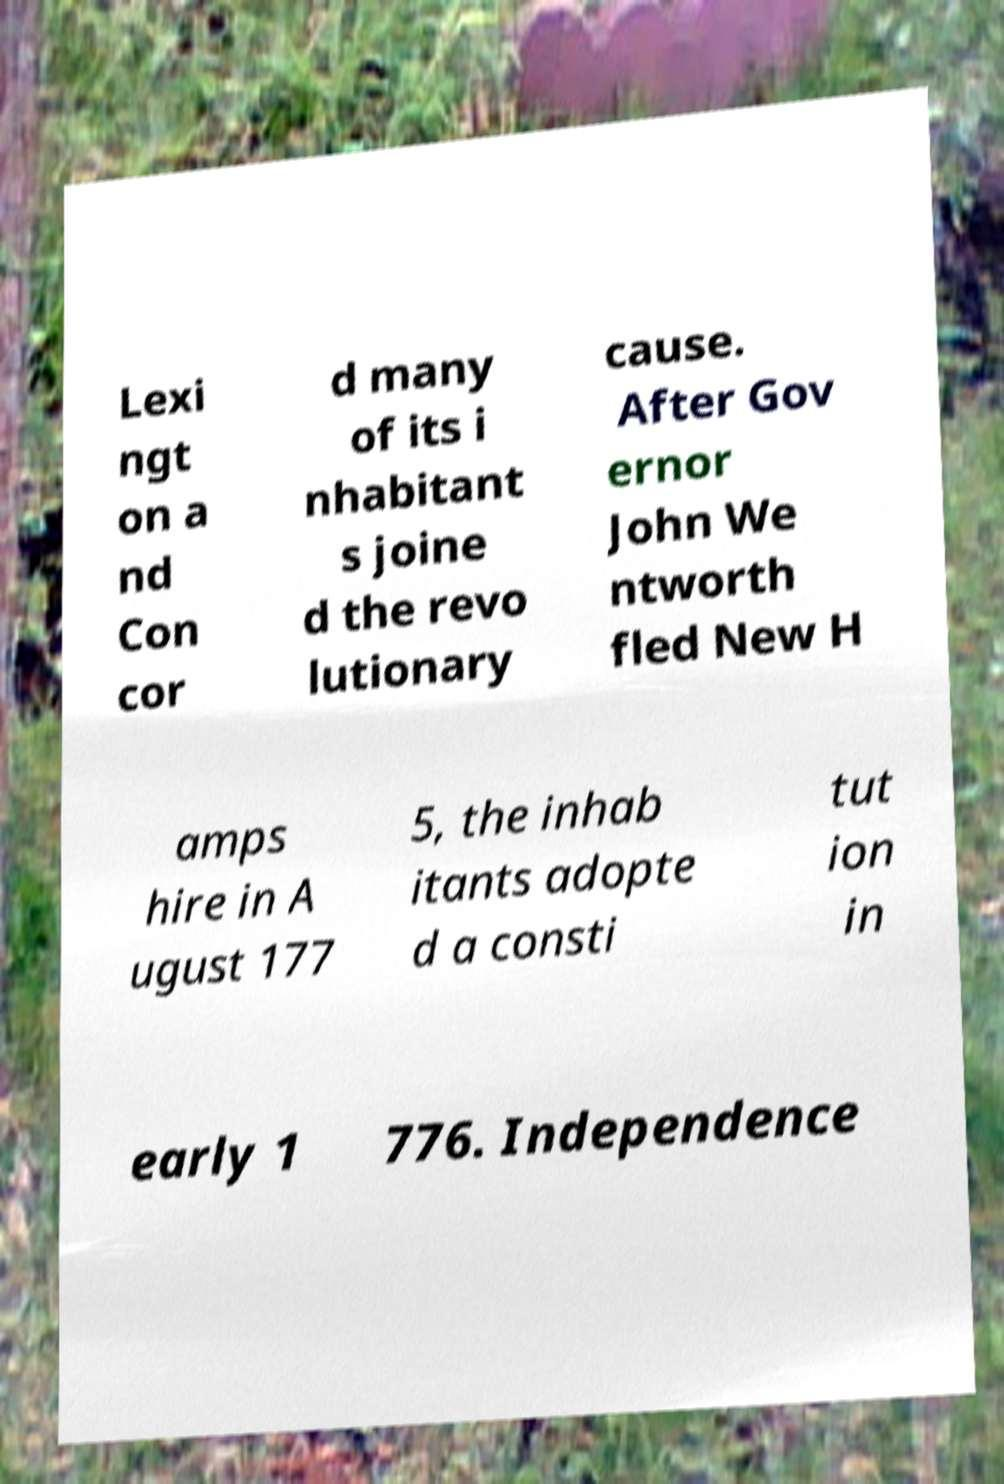Can you accurately transcribe the text from the provided image for me? Lexi ngt on a nd Con cor d many of its i nhabitant s joine d the revo lutionary cause. After Gov ernor John We ntworth fled New H amps hire in A ugust 177 5, the inhab itants adopte d a consti tut ion in early 1 776. Independence 